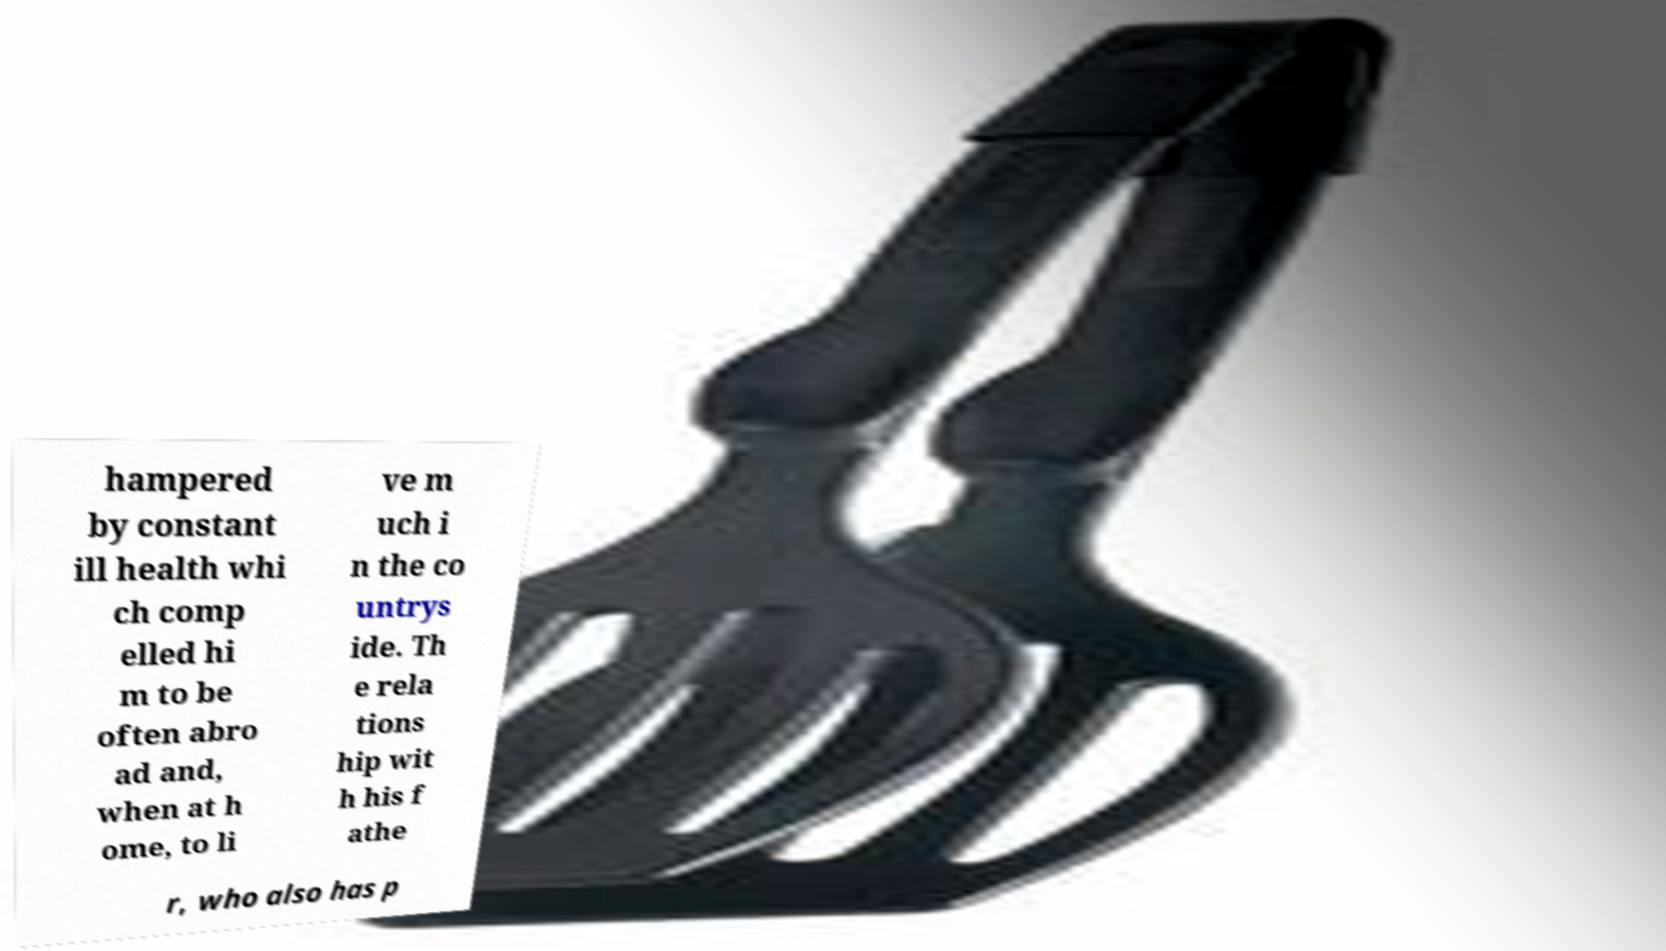Can you read and provide the text displayed in the image?This photo seems to have some interesting text. Can you extract and type it out for me? hampered by constant ill health whi ch comp elled hi m to be often abro ad and, when at h ome, to li ve m uch i n the co untrys ide. Th e rela tions hip wit h his f athe r, who also has p 